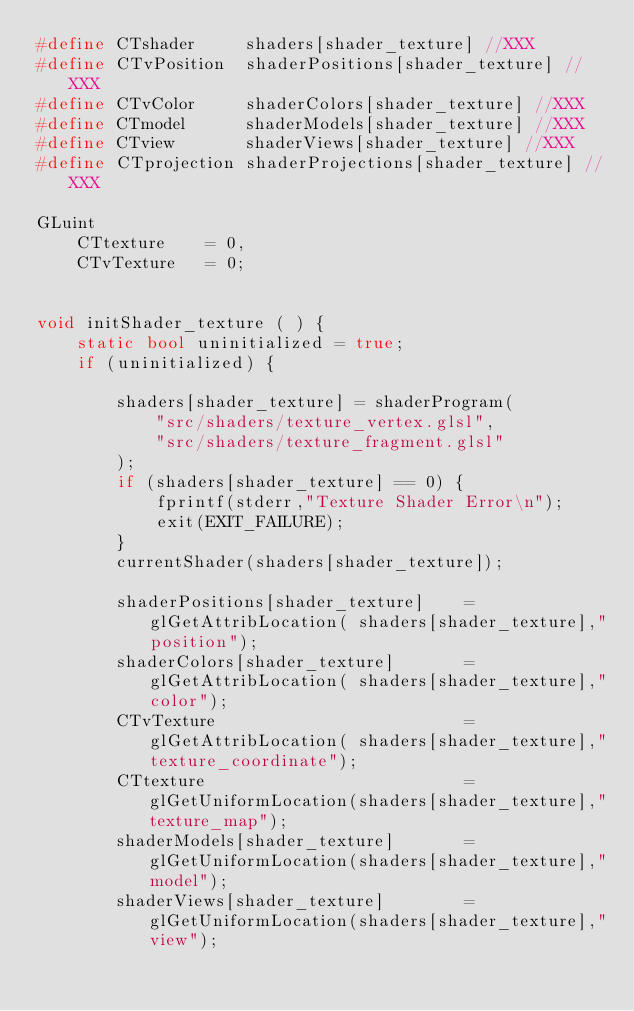<code> <loc_0><loc_0><loc_500><loc_500><_C++_>#define CTshader     shaders[shader_texture] //XXX
#define CTvPosition  shaderPositions[shader_texture] //XXX
#define CTvColor     shaderColors[shader_texture] //XXX
#define CTmodel      shaderModels[shader_texture] //XXX
#define CTview       shaderViews[shader_texture] //XXX
#define CTprojection shaderProjections[shader_texture] //XXX

GLuint
    CTtexture    = 0,
    CTvTexture   = 0;


void initShader_texture ( ) {
    static bool uninitialized = true;
    if (uninitialized) {

        shaders[shader_texture] = shaderProgram(
            "src/shaders/texture_vertex.glsl",
            "src/shaders/texture_fragment.glsl"
        );
        if (shaders[shader_texture] == 0) {
            fprintf(stderr,"Texture Shader Error\n");
            exit(EXIT_FAILURE);
        }
        currentShader(shaders[shader_texture]);

        shaderPositions[shader_texture]    = glGetAttribLocation( shaders[shader_texture],"position");
        shaderColors[shader_texture]       = glGetAttribLocation( shaders[shader_texture],"color");
        CTvTexture                         = glGetAttribLocation( shaders[shader_texture],"texture_coordinate");
        CTtexture                          = glGetUniformLocation(shaders[shader_texture],"texture_map");
        shaderModels[shader_texture]       = glGetUniformLocation(shaders[shader_texture],"model");
        shaderViews[shader_texture]        = glGetUniformLocation(shaders[shader_texture],"view");</code> 